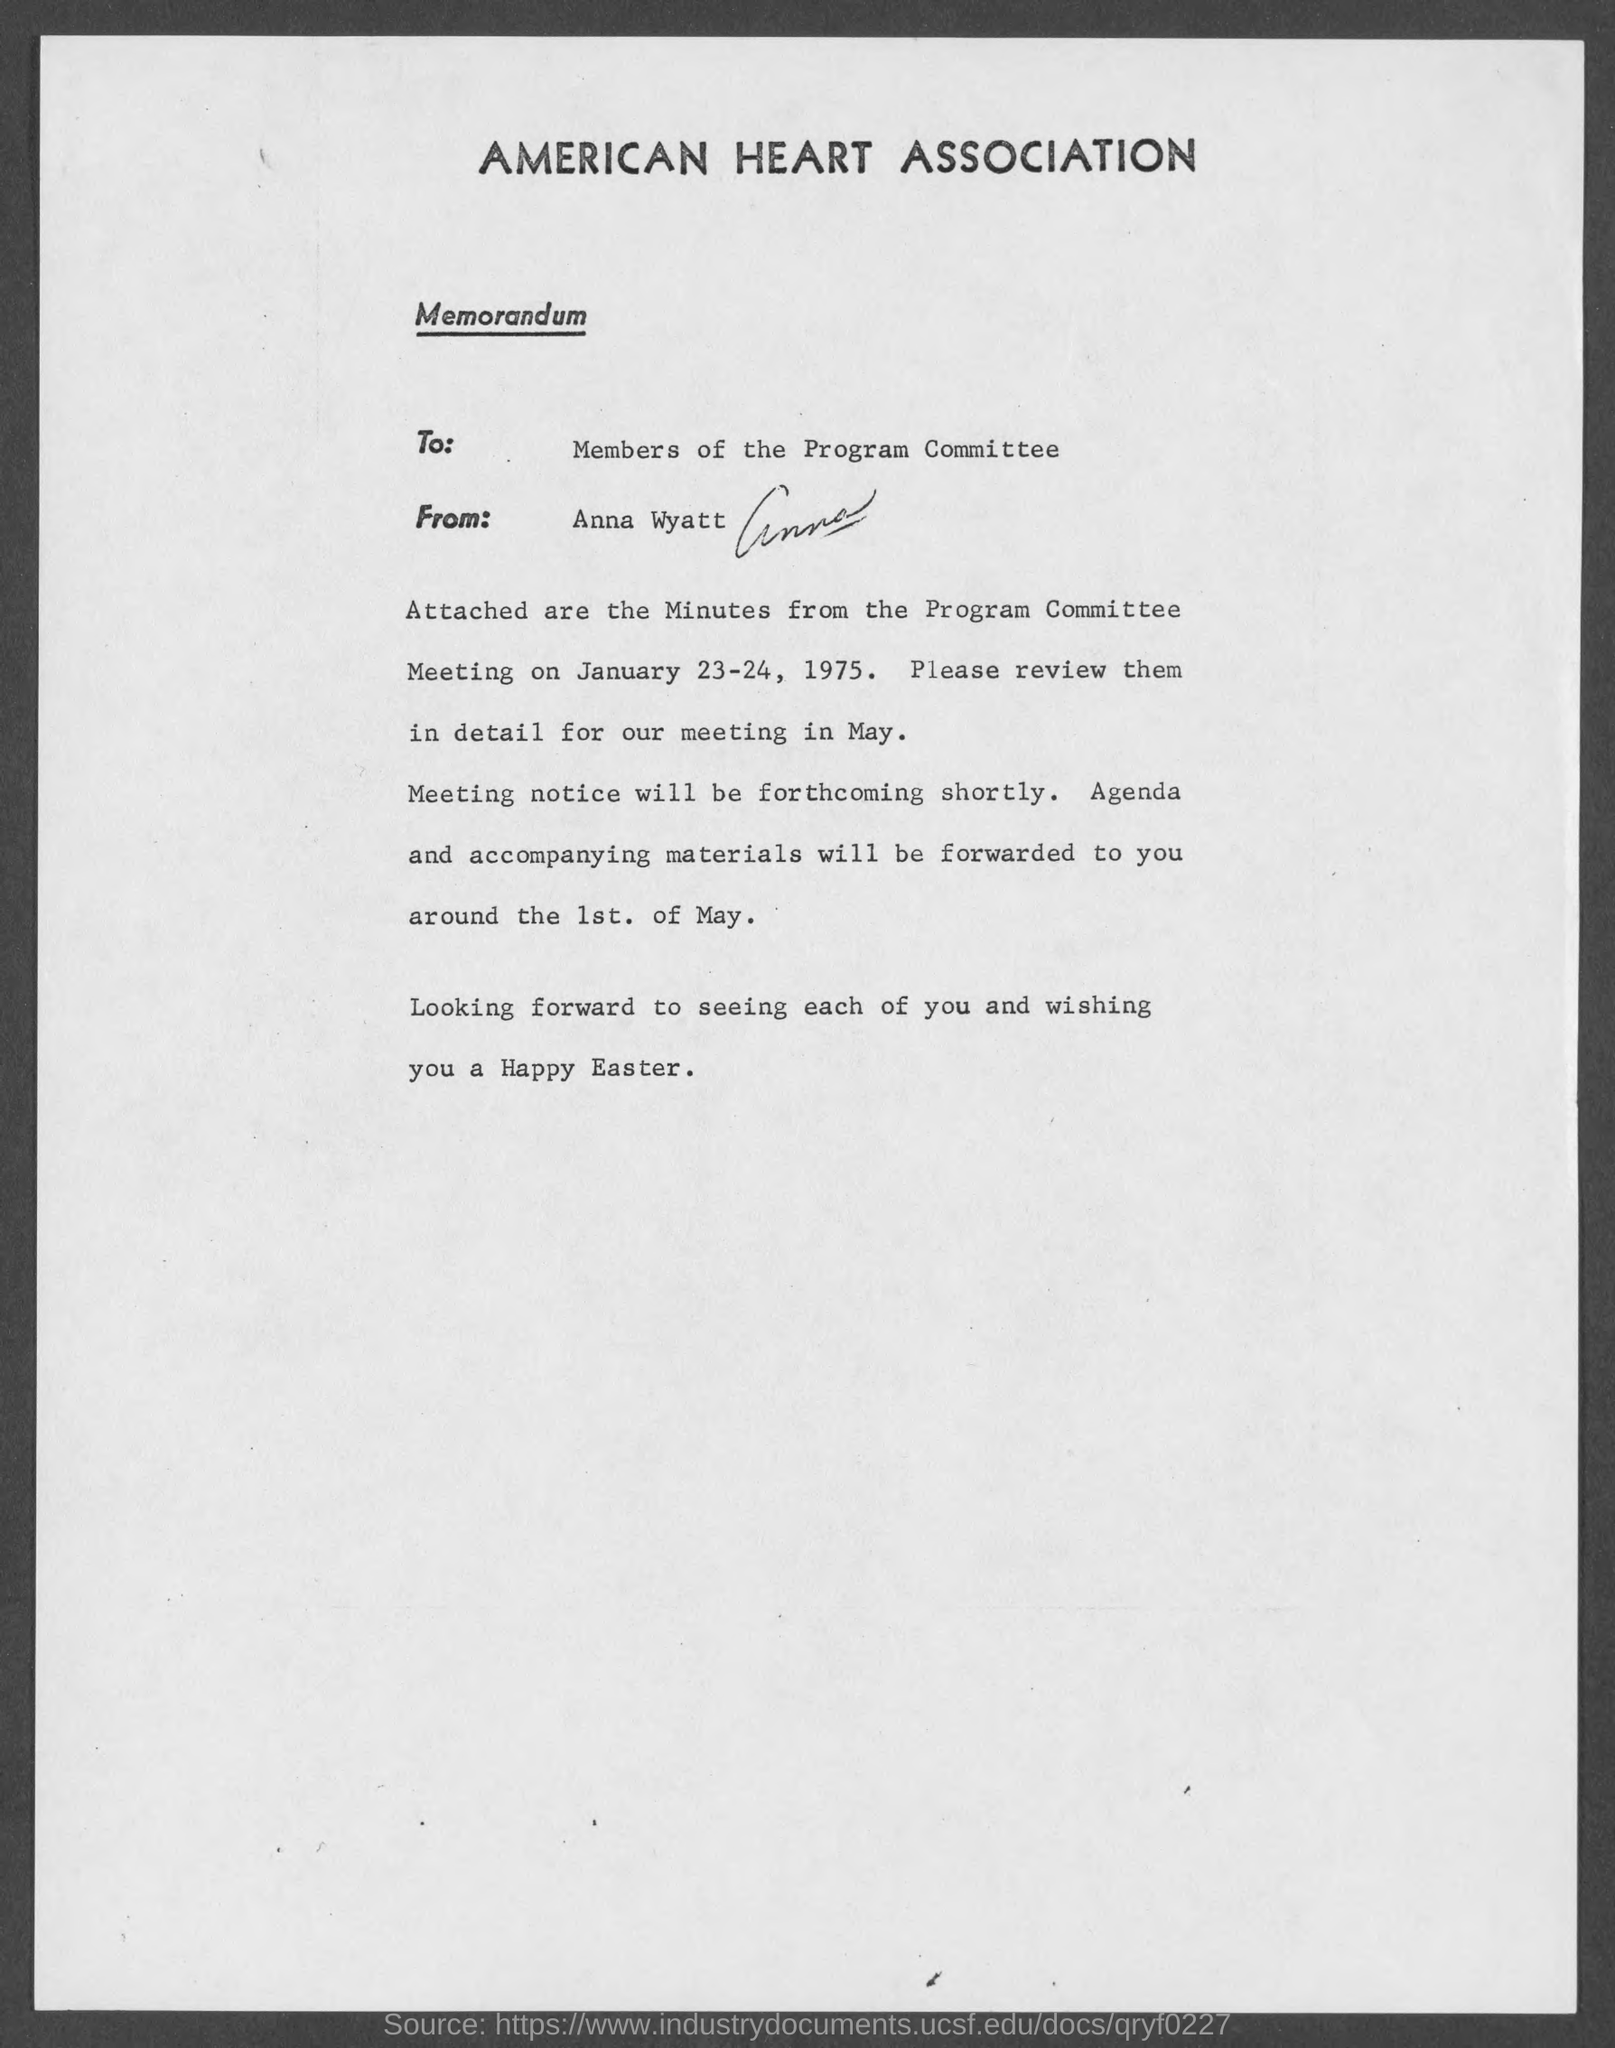Outline some significant characteristics in this image. The memorandum is addressed to the members of the Program Committee. The memorandum was sent by Anna Wyatt. 